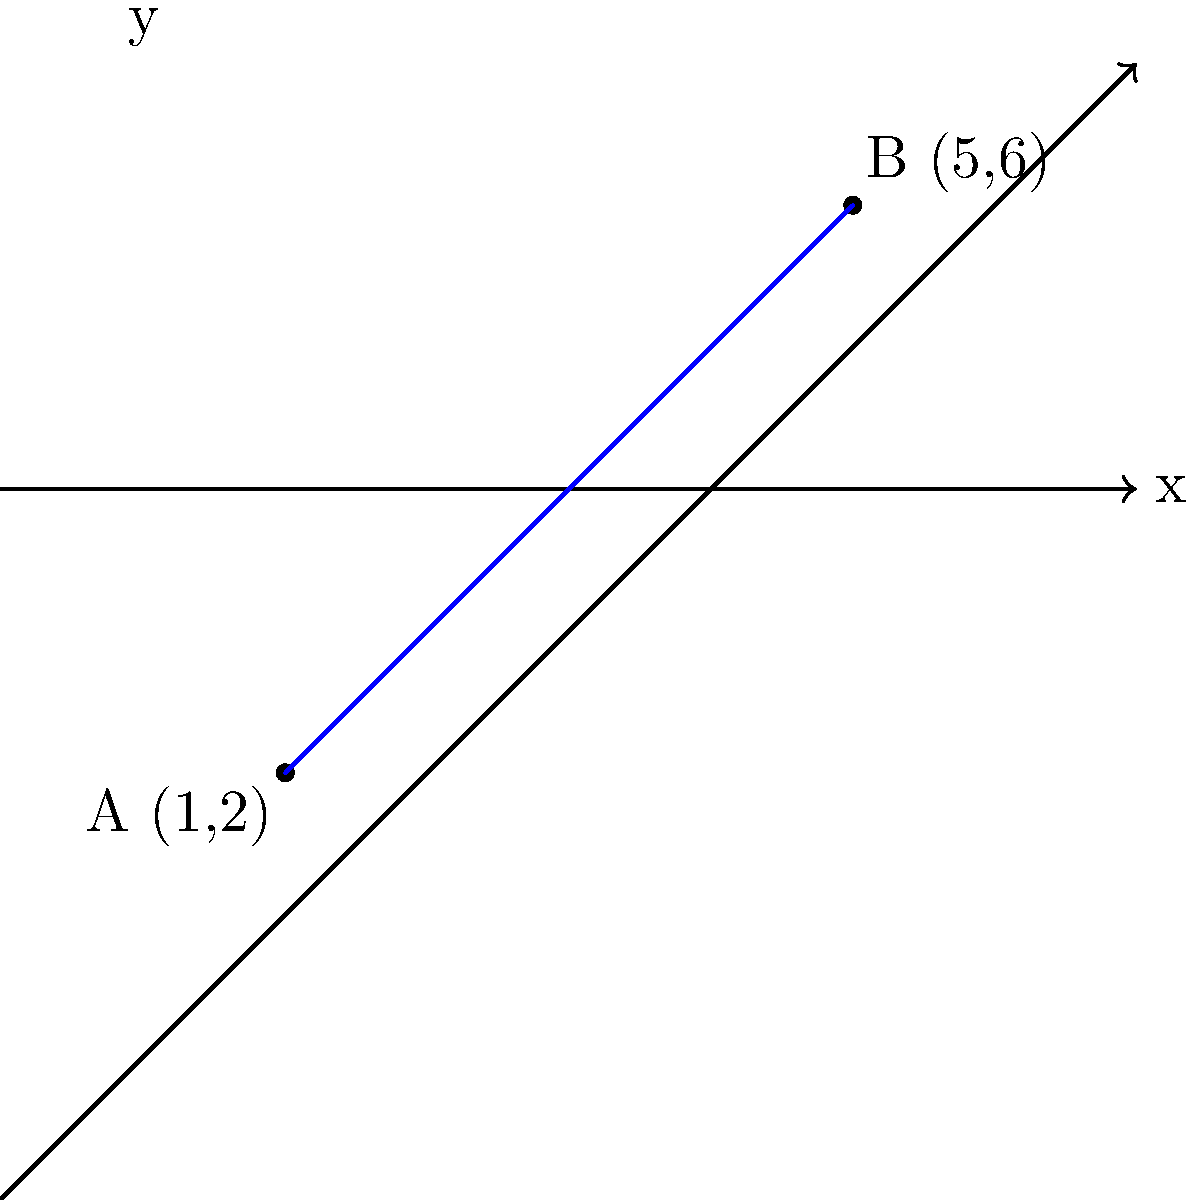As part of your neighborhood biking initiative, you need to calculate the distance between two bike stations. Station A is located at coordinates (1,2) and Station B is at (5,6) on a city map using a coordinate plane. What is the distance between these two stations? To find the distance between two points on a coordinate plane, we can use the distance formula, which is derived from the Pythagorean theorem:

Distance = $\sqrt{(x_2-x_1)^2 + (y_2-y_1)^2}$

Where $(x_1,y_1)$ are the coordinates of the first point and $(x_2,y_2)$ are the coordinates of the second point.

Let's solve this step by step:

1) Identify the coordinates:
   Station A: $(x_1,y_1) = (1,2)$
   Station B: $(x_2,y_2) = (5,6)$

2) Plug these into the distance formula:
   Distance = $\sqrt{(5-1)^2 + (6-2)^2}$

3) Simplify inside the parentheses:
   Distance = $\sqrt{4^2 + 4^2}$

4) Calculate the squares:
   Distance = $\sqrt{16 + 16}$

5) Add inside the square root:
   Distance = $\sqrt{32}$

6) Simplify the square root:
   Distance = $4\sqrt{2}$

Therefore, the distance between Station A and Station B is $4\sqrt{2}$ units.
Answer: $4\sqrt{2}$ units 